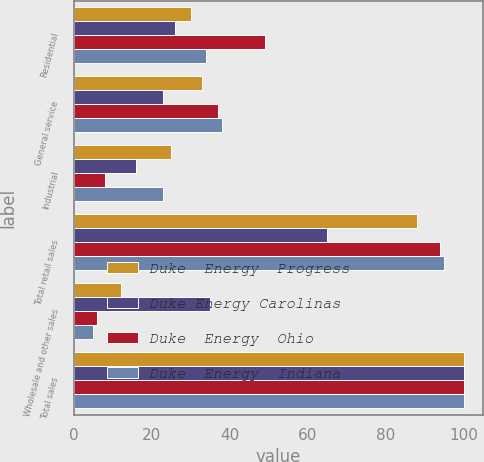Convert chart to OTSL. <chart><loc_0><loc_0><loc_500><loc_500><stacked_bar_chart><ecel><fcel>Residential<fcel>General service<fcel>Industrial<fcel>Total retail sales<fcel>Wholesale and other sales<fcel>Total sales<nl><fcel>Duke  Energy  Progress<fcel>30<fcel>33<fcel>25<fcel>88<fcel>12<fcel>100<nl><fcel>Duke Energy Carolinas<fcel>26<fcel>23<fcel>16<fcel>65<fcel>35<fcel>100<nl><fcel>Duke  Energy  Ohio<fcel>49<fcel>37<fcel>8<fcel>94<fcel>6<fcel>100<nl><fcel>Duke  Energy  Indiana<fcel>34<fcel>38<fcel>23<fcel>95<fcel>5<fcel>100<nl></chart> 